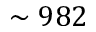Convert formula to latex. <formula><loc_0><loc_0><loc_500><loc_500>\sim 9 8 2</formula> 